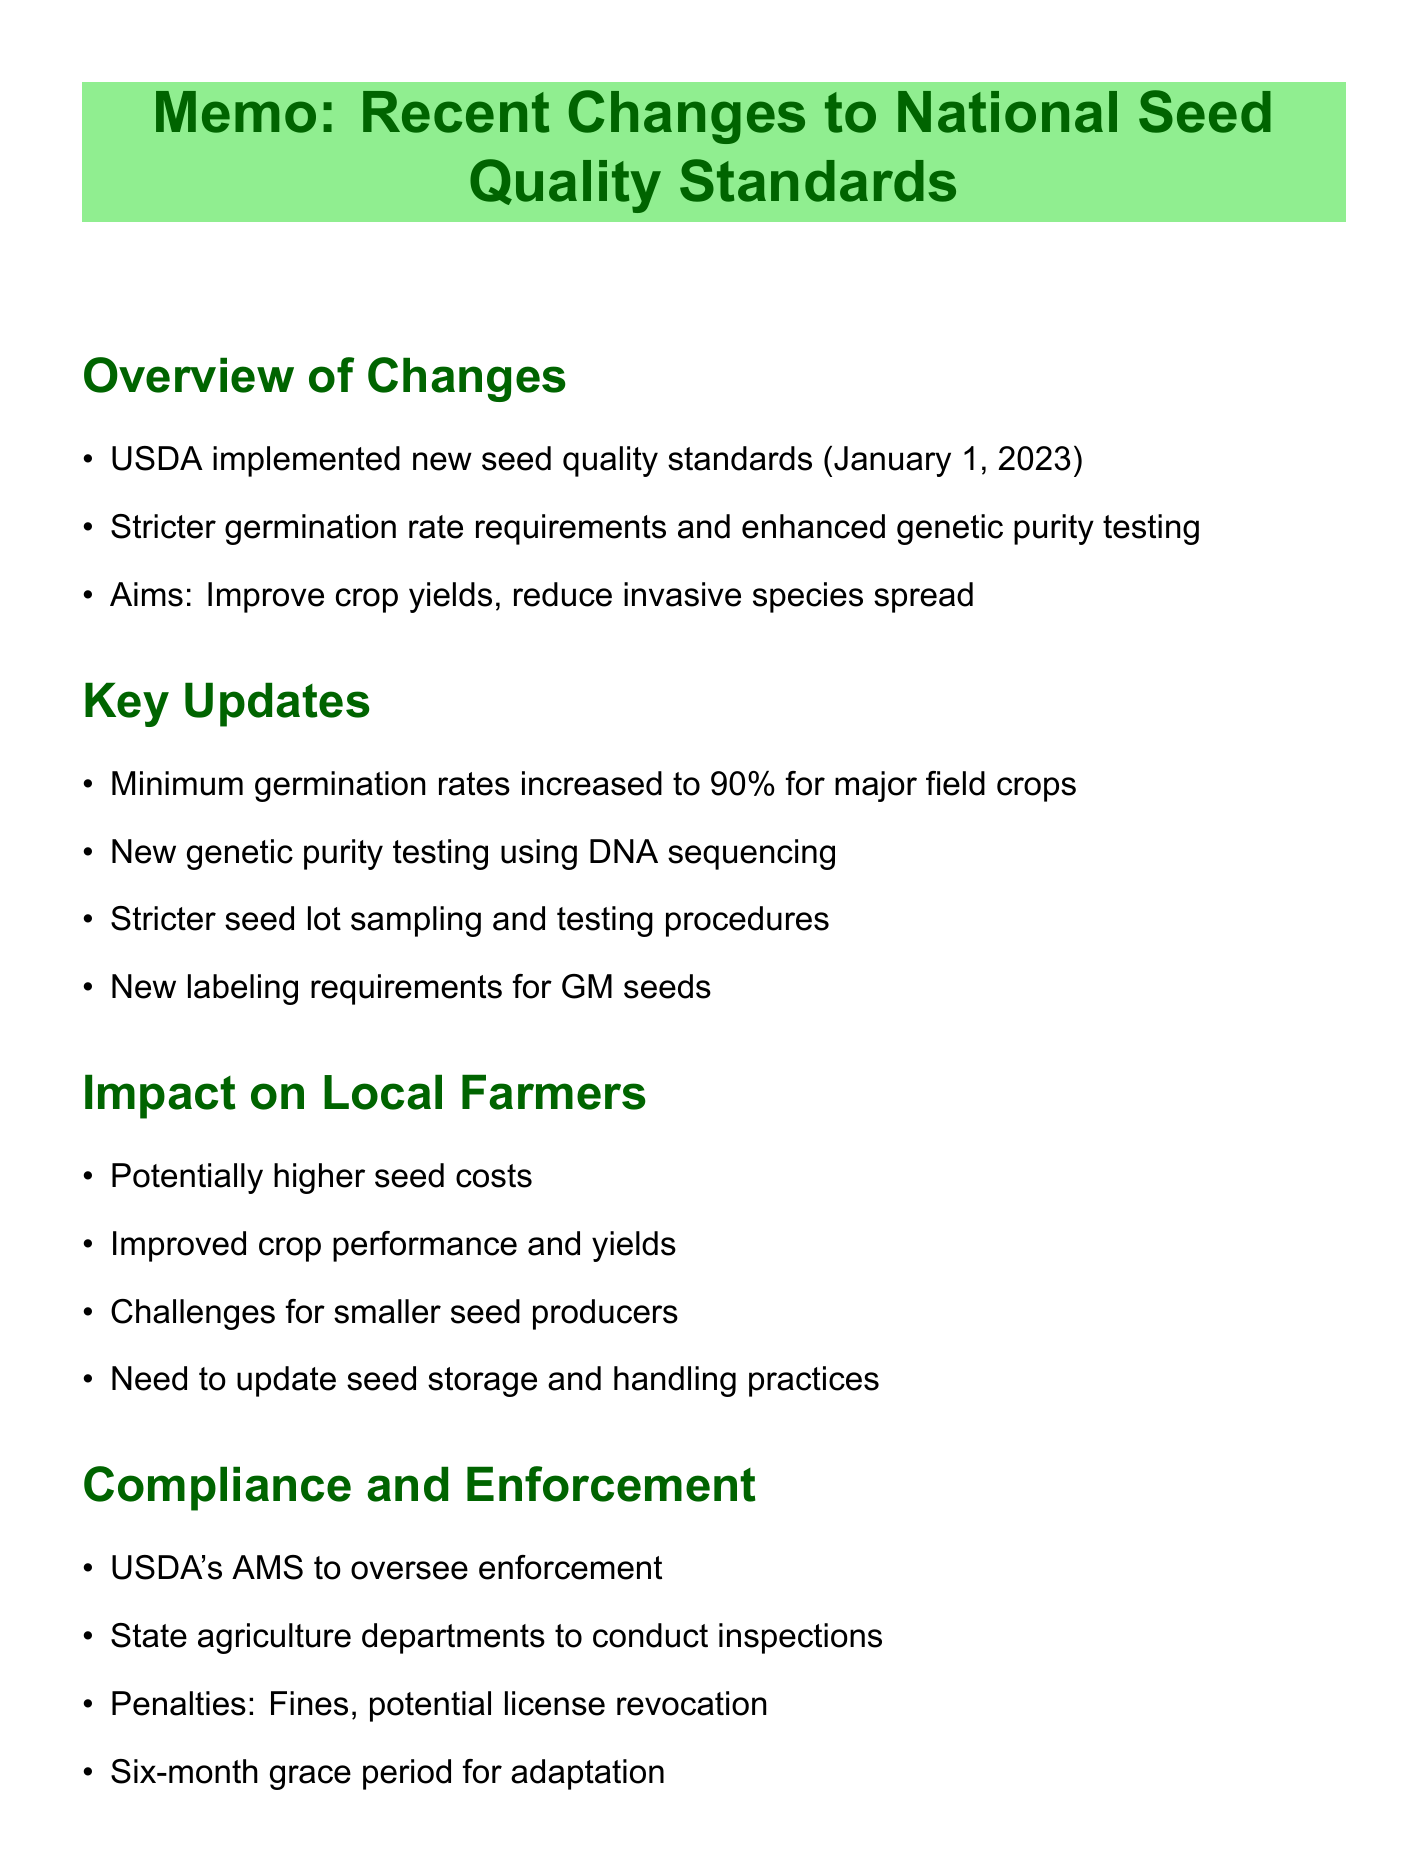What is the effective date of the new seed quality standards? The effective date is specified in the document as January 1, 2023.
Answer: January 1, 2023 What is the minimum germination rate for major field crops under the new standards? The document states that the minimum germination rate has increased to 90%.
Answer: 90% Which organization oversees the enforcement of the new seed quality standards? The document mentions the USDA's Agricultural Marketing Service (AMS) as the overseeing body.
Answer: USDA Agricultural Marketing Service (AMS) What type of testing is now required for genetic purity? The memo describes the advanced testing requirement as DNA sequencing techniques.
Answer: DNA sequencing techniques How long is the grace period for seed producers to adapt to the new requirements? The document specifies that there is a six-month grace period allowed.
Answer: Six months Why might smaller seed producers face challenges under the new regulations? The document indicates that smaller seed producers may struggle to meet the new standards, implying resource constraints.
Answer: New standards What support is being offered to help farmers adapt to the new standards? The memo lists USDA workshops and online training as forms of support for adaptation.
Answer: Workshops and online training Who can farmers and seed producers contact for assistance regarding new seed standards? The document mentions the establishment of a helpline for questions and concerns.
Answer: Helpline What do the changes aim to improve? The memo clearly states that the aim is to improve crop yields and reduce the spread of invasive species.
Answer: Crop yields and reduce invasive species 